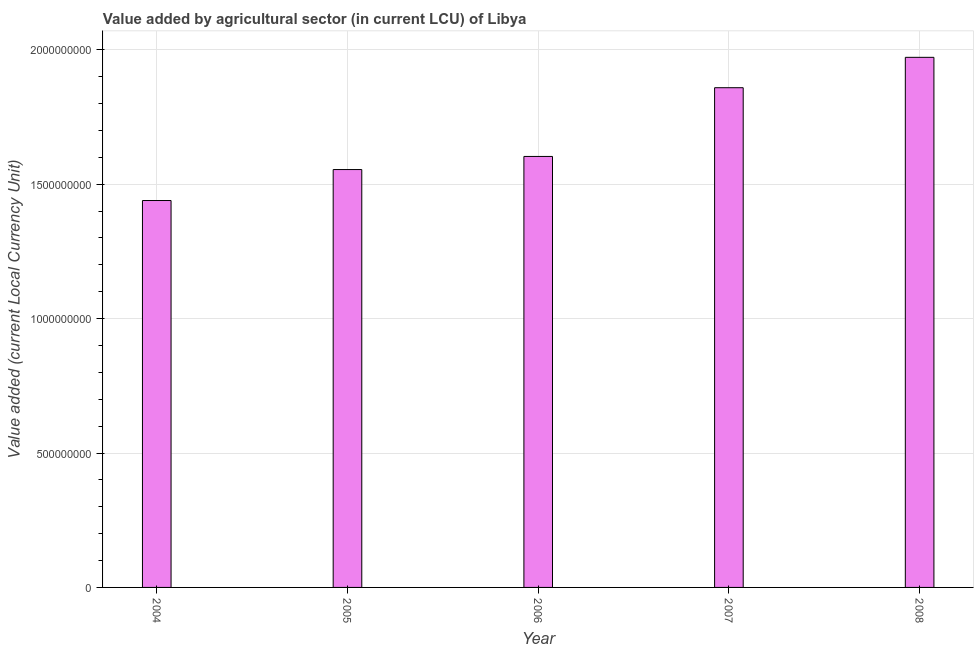Does the graph contain grids?
Offer a terse response. Yes. What is the title of the graph?
Your answer should be very brief. Value added by agricultural sector (in current LCU) of Libya. What is the label or title of the X-axis?
Make the answer very short. Year. What is the label or title of the Y-axis?
Provide a succinct answer. Value added (current Local Currency Unit). What is the value added by agriculture sector in 2004?
Keep it short and to the point. 1.44e+09. Across all years, what is the maximum value added by agriculture sector?
Provide a succinct answer. 1.97e+09. Across all years, what is the minimum value added by agriculture sector?
Provide a succinct answer. 1.44e+09. In which year was the value added by agriculture sector maximum?
Make the answer very short. 2008. In which year was the value added by agriculture sector minimum?
Ensure brevity in your answer.  2004. What is the sum of the value added by agriculture sector?
Give a very brief answer. 8.43e+09. What is the difference between the value added by agriculture sector in 2005 and 2008?
Provide a succinct answer. -4.18e+08. What is the average value added by agriculture sector per year?
Provide a succinct answer. 1.69e+09. What is the median value added by agriculture sector?
Your answer should be compact. 1.60e+09. Do a majority of the years between 2008 and 2005 (inclusive) have value added by agriculture sector greater than 200000000 LCU?
Your answer should be very brief. Yes. What is the ratio of the value added by agriculture sector in 2004 to that in 2006?
Offer a very short reply. 0.9. What is the difference between the highest and the second highest value added by agriculture sector?
Your answer should be very brief. 1.13e+08. What is the difference between the highest and the lowest value added by agriculture sector?
Keep it short and to the point. 5.33e+08. In how many years, is the value added by agriculture sector greater than the average value added by agriculture sector taken over all years?
Keep it short and to the point. 2. What is the difference between two consecutive major ticks on the Y-axis?
Provide a short and direct response. 5.00e+08. What is the Value added (current Local Currency Unit) of 2004?
Provide a short and direct response. 1.44e+09. What is the Value added (current Local Currency Unit) in 2005?
Your response must be concise. 1.55e+09. What is the Value added (current Local Currency Unit) of 2006?
Offer a terse response. 1.60e+09. What is the Value added (current Local Currency Unit) in 2007?
Your answer should be compact. 1.86e+09. What is the Value added (current Local Currency Unit) in 2008?
Your response must be concise. 1.97e+09. What is the difference between the Value added (current Local Currency Unit) in 2004 and 2005?
Your answer should be very brief. -1.15e+08. What is the difference between the Value added (current Local Currency Unit) in 2004 and 2006?
Offer a very short reply. -1.64e+08. What is the difference between the Value added (current Local Currency Unit) in 2004 and 2007?
Provide a succinct answer. -4.20e+08. What is the difference between the Value added (current Local Currency Unit) in 2004 and 2008?
Offer a terse response. -5.33e+08. What is the difference between the Value added (current Local Currency Unit) in 2005 and 2006?
Your response must be concise. -4.88e+07. What is the difference between the Value added (current Local Currency Unit) in 2005 and 2007?
Offer a very short reply. -3.04e+08. What is the difference between the Value added (current Local Currency Unit) in 2005 and 2008?
Make the answer very short. -4.18e+08. What is the difference between the Value added (current Local Currency Unit) in 2006 and 2007?
Your answer should be very brief. -2.56e+08. What is the difference between the Value added (current Local Currency Unit) in 2006 and 2008?
Your response must be concise. -3.69e+08. What is the difference between the Value added (current Local Currency Unit) in 2007 and 2008?
Give a very brief answer. -1.13e+08. What is the ratio of the Value added (current Local Currency Unit) in 2004 to that in 2005?
Your answer should be compact. 0.93. What is the ratio of the Value added (current Local Currency Unit) in 2004 to that in 2006?
Give a very brief answer. 0.9. What is the ratio of the Value added (current Local Currency Unit) in 2004 to that in 2007?
Your answer should be compact. 0.77. What is the ratio of the Value added (current Local Currency Unit) in 2004 to that in 2008?
Offer a very short reply. 0.73. What is the ratio of the Value added (current Local Currency Unit) in 2005 to that in 2006?
Keep it short and to the point. 0.97. What is the ratio of the Value added (current Local Currency Unit) in 2005 to that in 2007?
Provide a short and direct response. 0.84. What is the ratio of the Value added (current Local Currency Unit) in 2005 to that in 2008?
Provide a short and direct response. 0.79. What is the ratio of the Value added (current Local Currency Unit) in 2006 to that in 2007?
Provide a succinct answer. 0.86. What is the ratio of the Value added (current Local Currency Unit) in 2006 to that in 2008?
Your answer should be very brief. 0.81. What is the ratio of the Value added (current Local Currency Unit) in 2007 to that in 2008?
Provide a short and direct response. 0.94. 